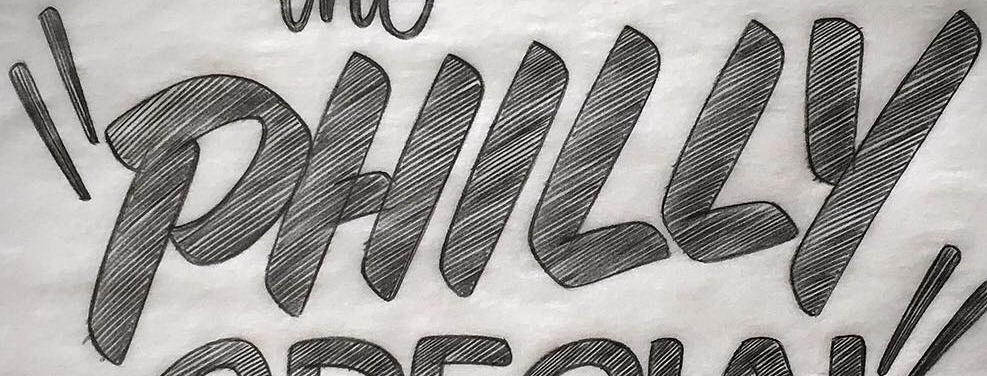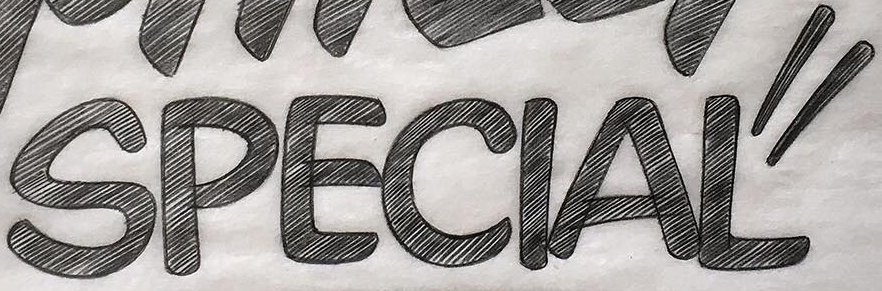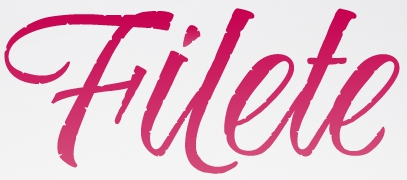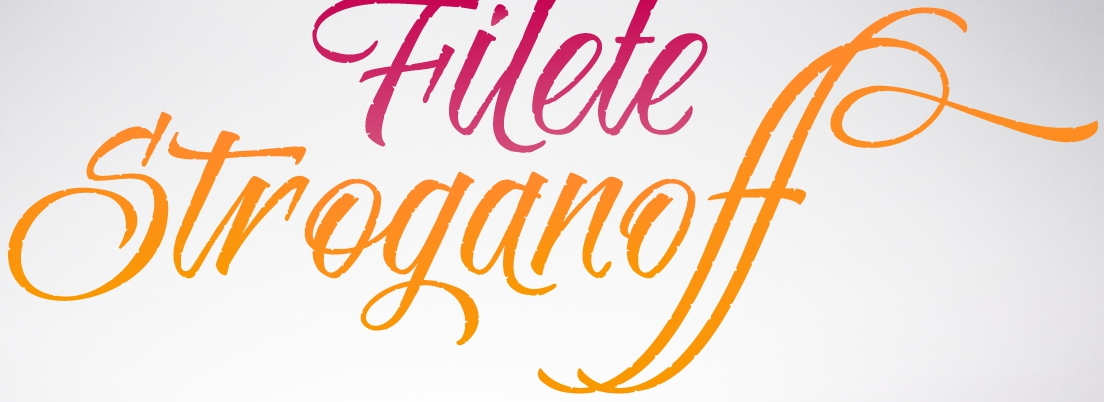Transcribe the words shown in these images in order, separated by a semicolon. "PHILLY; SPECIAL"; Hilete; Stroganoff 